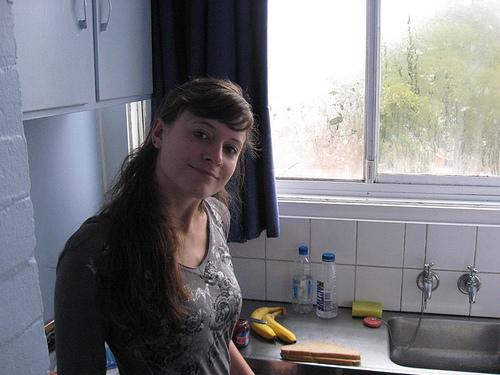How many bananas are on the counter?
Concise answer only. 2. Do you think the girl likes bananas?
Write a very short answer. Yes. Is there any dish liquid on the sink?
Keep it brief. No. 